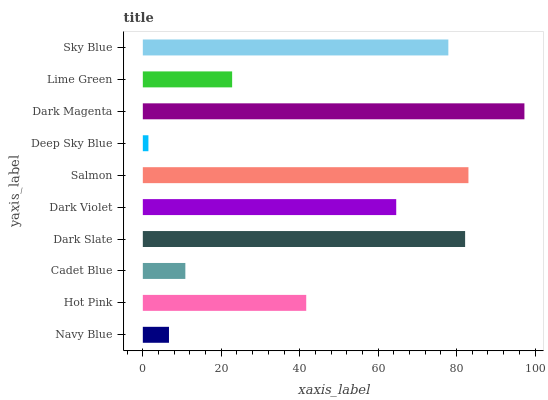Is Deep Sky Blue the minimum?
Answer yes or no. Yes. Is Dark Magenta the maximum?
Answer yes or no. Yes. Is Hot Pink the minimum?
Answer yes or no. No. Is Hot Pink the maximum?
Answer yes or no. No. Is Hot Pink greater than Navy Blue?
Answer yes or no. Yes. Is Navy Blue less than Hot Pink?
Answer yes or no. Yes. Is Navy Blue greater than Hot Pink?
Answer yes or no. No. Is Hot Pink less than Navy Blue?
Answer yes or no. No. Is Dark Violet the high median?
Answer yes or no. Yes. Is Hot Pink the low median?
Answer yes or no. Yes. Is Salmon the high median?
Answer yes or no. No. Is Navy Blue the low median?
Answer yes or no. No. 